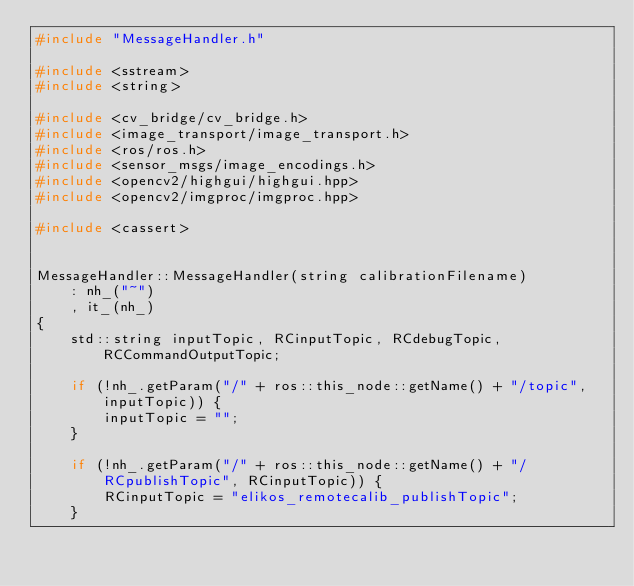<code> <loc_0><loc_0><loc_500><loc_500><_C++_>#include "MessageHandler.h"

#include <sstream>
#include <string>

#include <cv_bridge/cv_bridge.h>
#include <image_transport/image_transport.h>
#include <ros/ros.h>
#include <sensor_msgs/image_encodings.h>
#include <opencv2/highgui/highgui.hpp>
#include <opencv2/imgproc/imgproc.hpp>

#include <cassert>


MessageHandler::MessageHandler(string calibrationFilename) 
    : nh_("~")
    , it_(nh_)
{
    std::string inputTopic, RCinputTopic, RCdebugTopic, RCCommandOutputTopic;

    if (!nh_.getParam("/" + ros::this_node::getName() + "/topic", inputTopic)) {
        inputTopic = "";
    }

    if (!nh_.getParam("/" + ros::this_node::getName() + "/RCpublishTopic", RCinputTopic)) {
        RCinputTopic = "elikos_remotecalib_publishTopic";
    }
</code> 